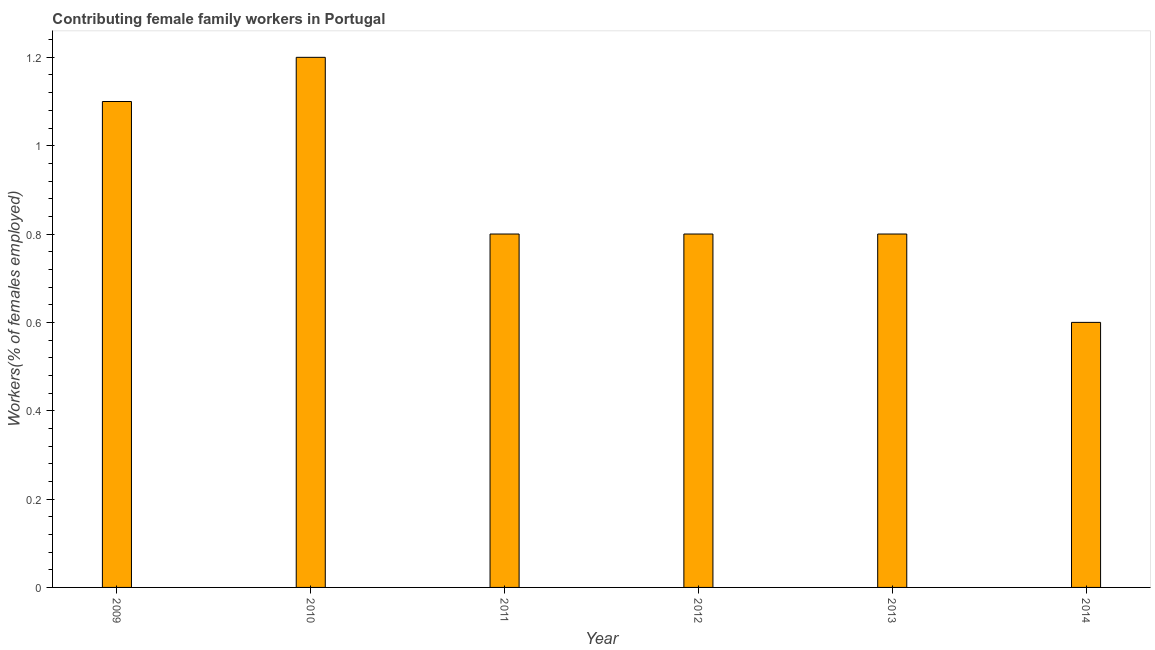Does the graph contain any zero values?
Keep it short and to the point. No. What is the title of the graph?
Your response must be concise. Contributing female family workers in Portugal. What is the label or title of the Y-axis?
Give a very brief answer. Workers(% of females employed). What is the contributing female family workers in 2012?
Offer a terse response. 0.8. Across all years, what is the maximum contributing female family workers?
Give a very brief answer. 1.2. Across all years, what is the minimum contributing female family workers?
Provide a succinct answer. 0.6. In which year was the contributing female family workers minimum?
Give a very brief answer. 2014. What is the sum of the contributing female family workers?
Provide a succinct answer. 5.3. What is the difference between the contributing female family workers in 2012 and 2014?
Your response must be concise. 0.2. What is the average contributing female family workers per year?
Provide a succinct answer. 0.88. What is the median contributing female family workers?
Your answer should be compact. 0.8. In how many years, is the contributing female family workers greater than 0.52 %?
Give a very brief answer. 6. What is the ratio of the contributing female family workers in 2009 to that in 2010?
Provide a succinct answer. 0.92. What is the difference between the highest and the second highest contributing female family workers?
Your answer should be very brief. 0.1. Are all the bars in the graph horizontal?
Offer a very short reply. No. How many years are there in the graph?
Give a very brief answer. 6. What is the Workers(% of females employed) of 2009?
Your answer should be compact. 1.1. What is the Workers(% of females employed) in 2010?
Provide a short and direct response. 1.2. What is the Workers(% of females employed) in 2011?
Offer a terse response. 0.8. What is the Workers(% of females employed) of 2012?
Make the answer very short. 0.8. What is the Workers(% of females employed) of 2013?
Offer a terse response. 0.8. What is the Workers(% of females employed) in 2014?
Offer a terse response. 0.6. What is the difference between the Workers(% of females employed) in 2009 and 2010?
Give a very brief answer. -0.1. What is the difference between the Workers(% of females employed) in 2009 and 2011?
Make the answer very short. 0.3. What is the difference between the Workers(% of females employed) in 2009 and 2012?
Ensure brevity in your answer.  0.3. What is the difference between the Workers(% of females employed) in 2009 and 2013?
Keep it short and to the point. 0.3. What is the difference between the Workers(% of females employed) in 2010 and 2011?
Offer a terse response. 0.4. What is the difference between the Workers(% of females employed) in 2010 and 2012?
Give a very brief answer. 0.4. What is the difference between the Workers(% of females employed) in 2010 and 2014?
Make the answer very short. 0.6. What is the difference between the Workers(% of females employed) in 2011 and 2014?
Offer a very short reply. 0.2. What is the difference between the Workers(% of females employed) in 2013 and 2014?
Make the answer very short. 0.2. What is the ratio of the Workers(% of females employed) in 2009 to that in 2010?
Make the answer very short. 0.92. What is the ratio of the Workers(% of females employed) in 2009 to that in 2011?
Your response must be concise. 1.38. What is the ratio of the Workers(% of females employed) in 2009 to that in 2012?
Your answer should be very brief. 1.38. What is the ratio of the Workers(% of females employed) in 2009 to that in 2013?
Offer a very short reply. 1.38. What is the ratio of the Workers(% of females employed) in 2009 to that in 2014?
Ensure brevity in your answer.  1.83. What is the ratio of the Workers(% of females employed) in 2010 to that in 2012?
Offer a very short reply. 1.5. What is the ratio of the Workers(% of females employed) in 2010 to that in 2014?
Keep it short and to the point. 2. What is the ratio of the Workers(% of females employed) in 2011 to that in 2014?
Keep it short and to the point. 1.33. What is the ratio of the Workers(% of females employed) in 2012 to that in 2013?
Give a very brief answer. 1. What is the ratio of the Workers(% of females employed) in 2012 to that in 2014?
Make the answer very short. 1.33. What is the ratio of the Workers(% of females employed) in 2013 to that in 2014?
Your answer should be compact. 1.33. 